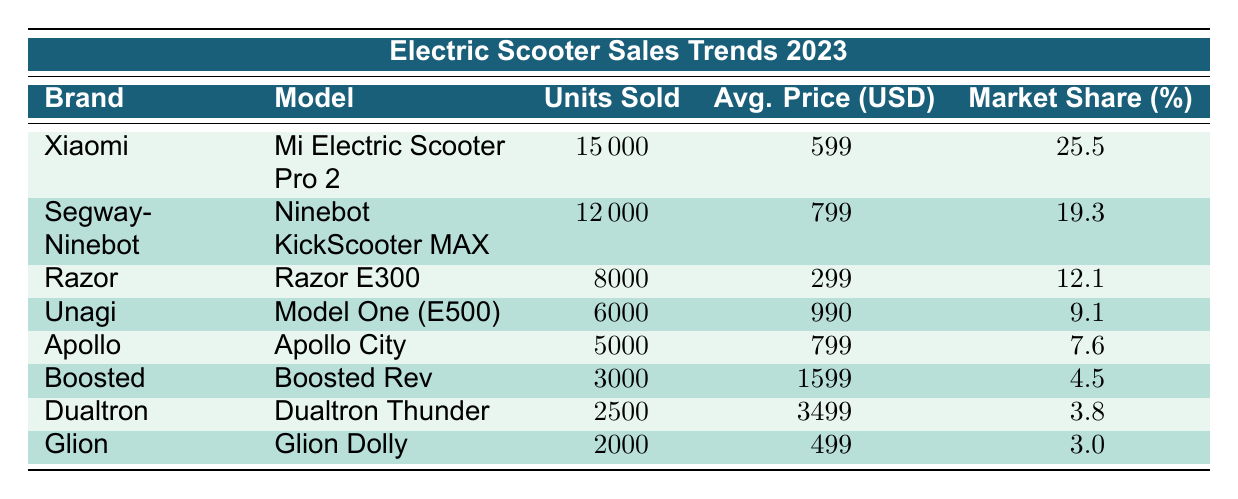What brand sold the highest number of electric scooters in 2023? By looking at the "Units Sold" column, Xiaomi has the highest value at 15,000 units compared to other brands listed in the table.
Answer: Xiaomi What is the average price of the Razor E300? The table lists that the Razor E300 has an average price of 299 USD.
Answer: 299 Which brand accounts for more than 10% market share? Looking at the "Market Share (%)" column, Xiaomi (25.5%), Segway-Ninebot (19.3%), and Razor (12.1%) are the brands that have a market share greater than 10%.
Answer: Yes What is the total number of units sold by Apollo and Unagi combined? The units sold by Apollo is 5,000 and by Unagi is 6,000. Adding these gives 5,000 + 6,000 = 11,000 units sold combined.
Answer: 11000 Is the average price of the Boosted Rev higher than the average price of the Xiaomi model? The average price of Boosted Rev is 1,599 USD and of the Xiaomi model is 599 USD. Since 1,599 > 599, it confirms that Boosted Rev is more expensive.
Answer: Yes What is the market share percentage of the Dualtron brand? The Dualtron brand has a market share percentage listed as 3.8% in the table.
Answer: 3.8 If we consider only models with units sold above 5,000, which model has the highest average price? The models with units sold above 5,000 are Xiaomi (599), Segway-Ninebot (799), and Unagi (990). Among these, the Unagi model has the highest average price of 990 USD.
Answer: 990 Which model sold the fewest units and what is its market share percentage? The model with the fewest units sold is Glion Dolly with 2,000 units sold. Its market share percentage is 3.0%.
Answer: 3.0 